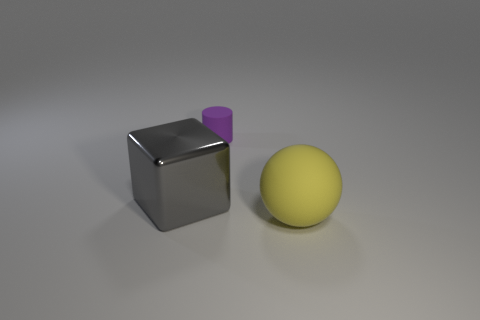There is a object that is on the left side of the large yellow object and to the right of the large gray metal object; what is its size?
Keep it short and to the point. Small. What number of other objects are the same material as the large ball?
Your response must be concise. 1. How big is the matte object behind the large yellow sphere?
Offer a terse response. Small. Do the rubber cylinder and the large matte sphere have the same color?
Provide a succinct answer. No. How many small objects are either blocks or things?
Provide a short and direct response. 1. Is there anything else that has the same color as the metal thing?
Ensure brevity in your answer.  No. Are there any big gray metal objects right of the small purple object?
Your answer should be very brief. No. What size is the matte object that is on the left side of the matte object on the right side of the purple thing?
Your response must be concise. Small. Is the number of spheres behind the big gray block the same as the number of small purple rubber cylinders that are to the left of the big yellow sphere?
Provide a short and direct response. No. There is a matte object that is on the left side of the yellow rubber ball; are there any gray objects that are to the right of it?
Provide a short and direct response. No. 